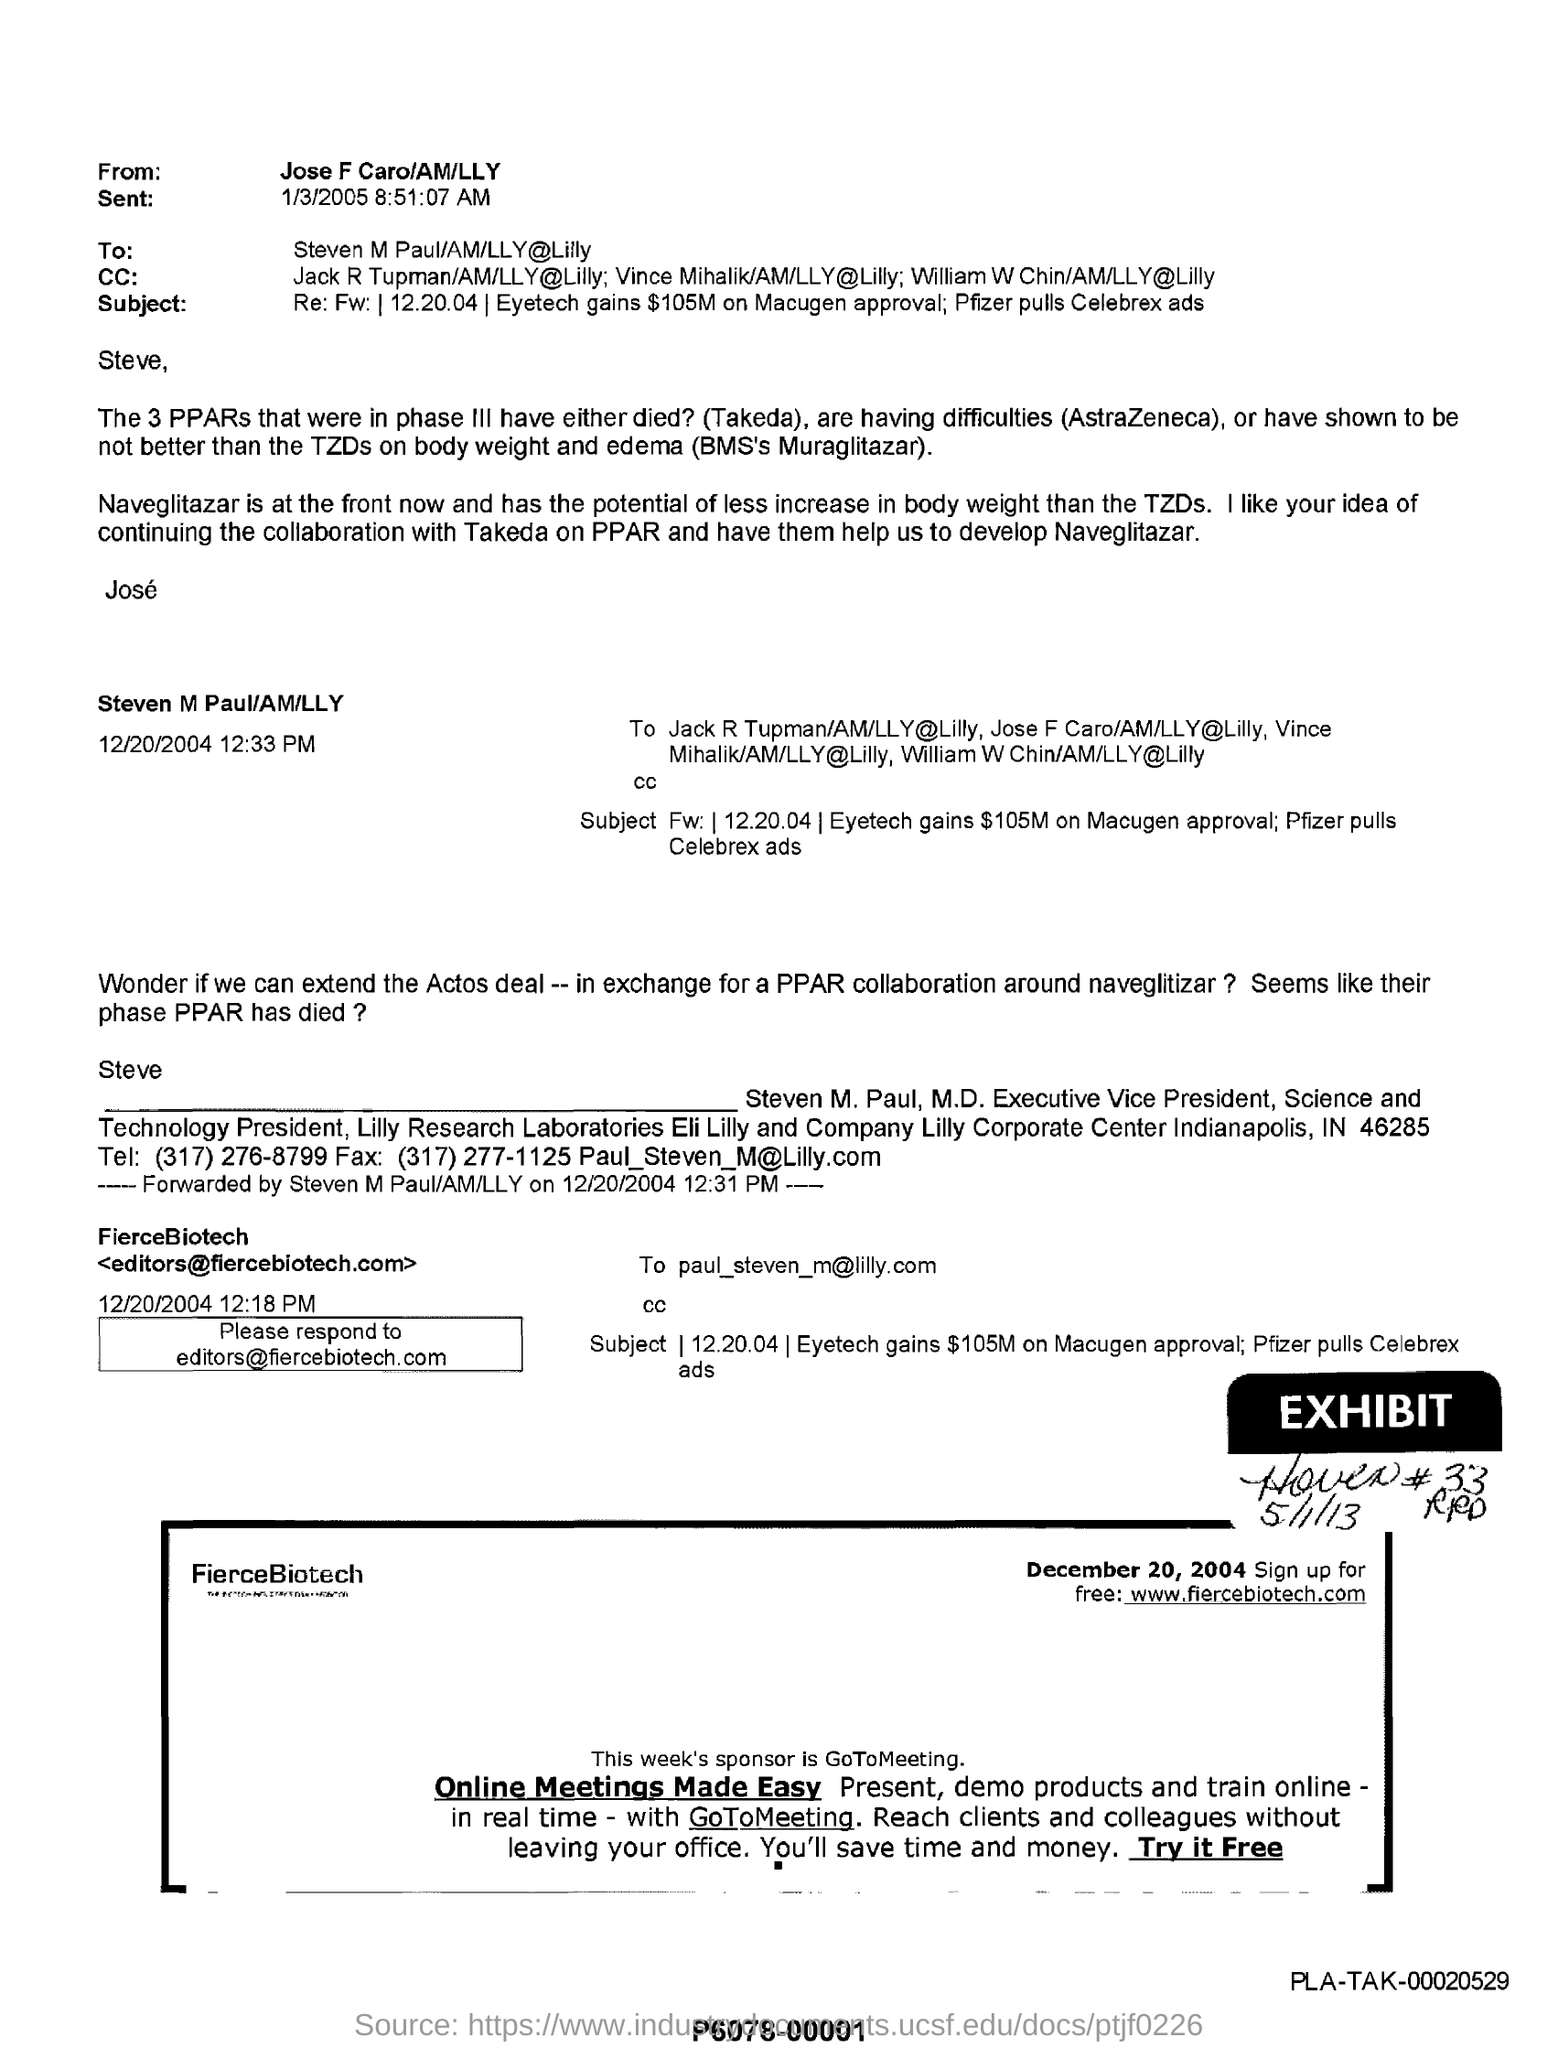List a handful of essential elements in this visual. The sender of this email is Jose F. Caro. 